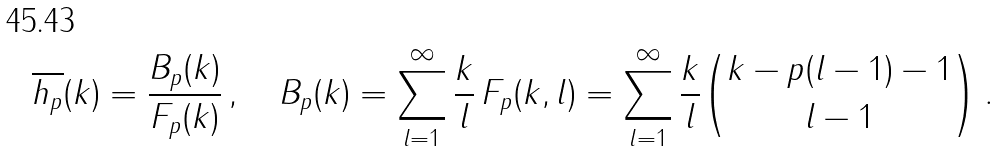Convert formula to latex. <formula><loc_0><loc_0><loc_500><loc_500>\overline { h _ { p } } ( k ) = \frac { B _ { p } ( k ) } { F _ { p } ( k ) } \, , \quad B _ { p } ( k ) = \sum _ { l = 1 } ^ { \infty } \frac { k } { l } \, F _ { p } ( k , l ) = \sum _ { l = 1 } ^ { \infty } \frac { k } { l } { k - p ( l - 1 ) - 1 \choose l - 1 } \, .</formula> 